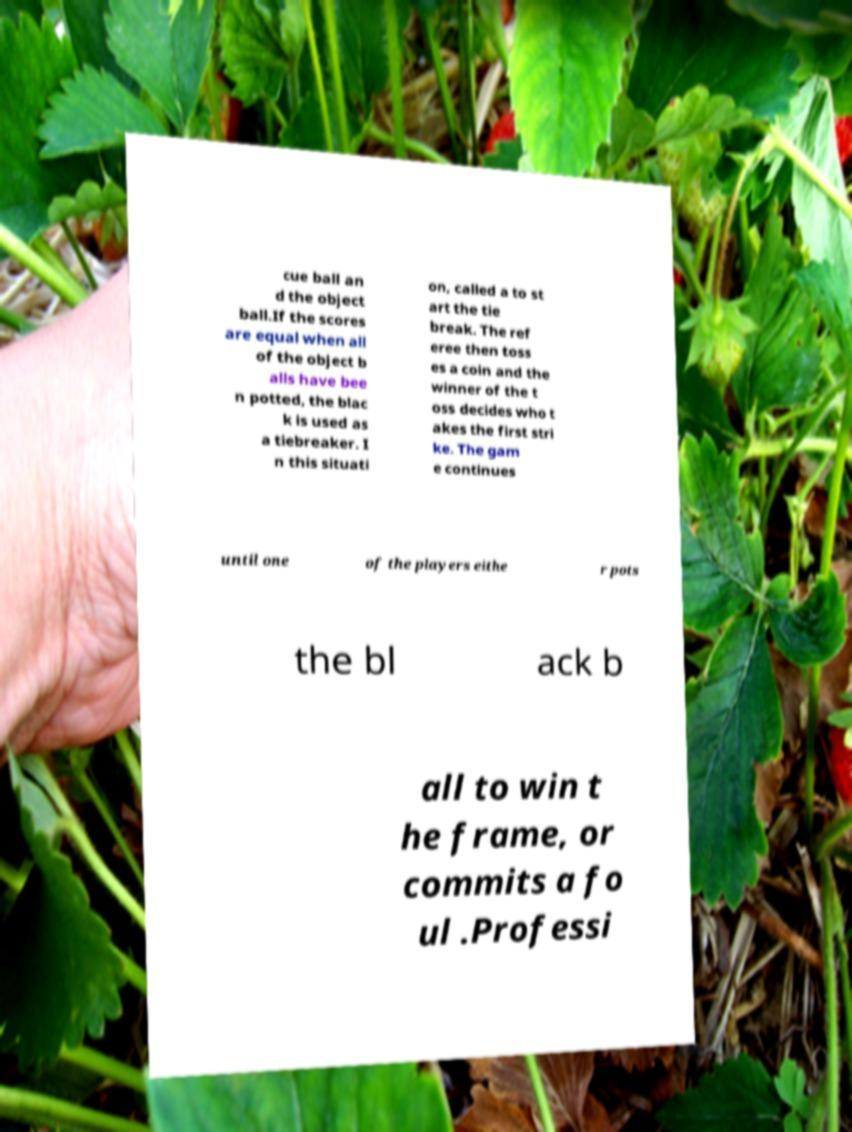Could you assist in decoding the text presented in this image and type it out clearly? cue ball an d the object ball.If the scores are equal when all of the object b alls have bee n potted, the blac k is used as a tiebreaker. I n this situati on, called a to st art the tie break. The ref eree then toss es a coin and the winner of the t oss decides who t akes the first stri ke. The gam e continues until one of the players eithe r pots the bl ack b all to win t he frame, or commits a fo ul .Professi 